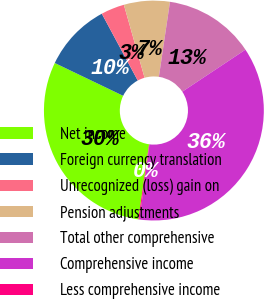<chart> <loc_0><loc_0><loc_500><loc_500><pie_chart><fcel>Net income<fcel>Foreign currency translation<fcel>Unrecognized (loss) gain on<fcel>Pension adjustments<fcel>Total other comprehensive<fcel>Comprehensive income<fcel>Less comprehensive income<nl><fcel>29.86%<fcel>10.03%<fcel>3.45%<fcel>6.74%<fcel>13.32%<fcel>36.43%<fcel>0.16%<nl></chart> 